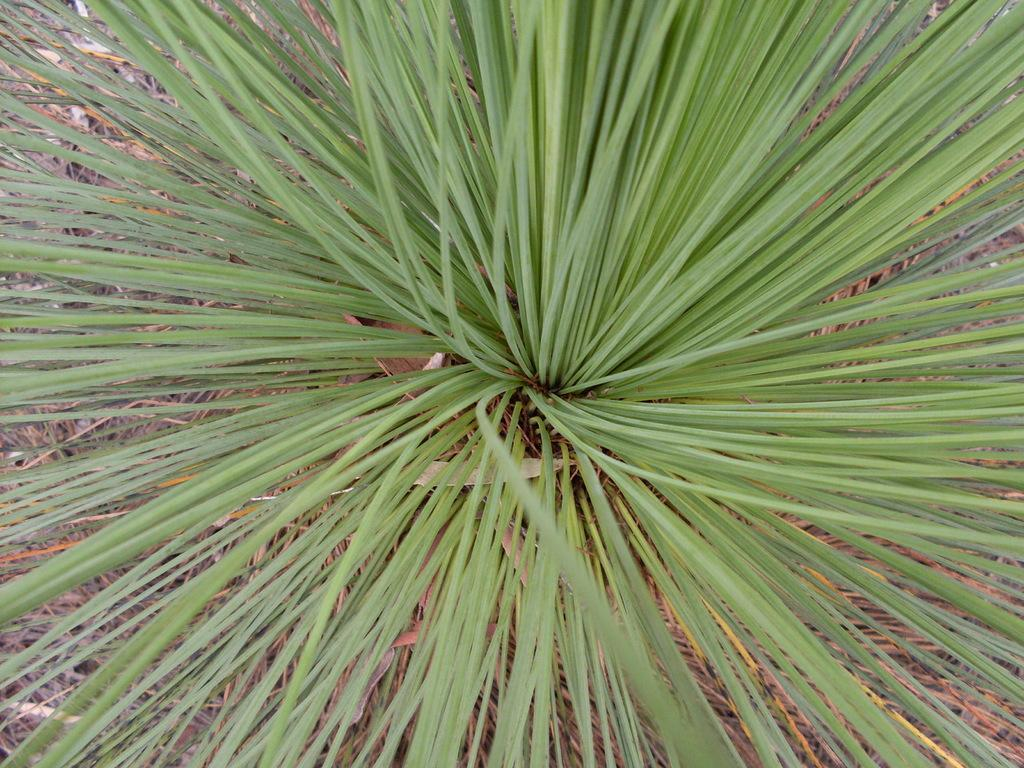What is located in the foreground of the image? There is a plant in the foreground of the image. What type of vegetation can be seen in the background of the image? There is grass visible in the background of the image. What type of boat can be seen in the image? There is no boat present in the image; it only features a plant in the foreground and grass in the background. 